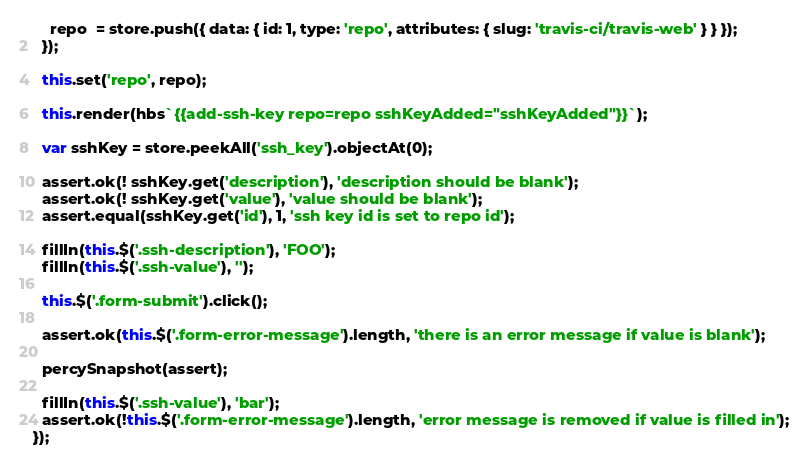Convert code to text. <code><loc_0><loc_0><loc_500><loc_500><_JavaScript_>    repo  = store.push({ data: { id: 1, type: 'repo', attributes: { slug: 'travis-ci/travis-web' } } });
  });

  this.set('repo', repo);

  this.render(hbs`{{add-ssh-key repo=repo sshKeyAdded="sshKeyAdded"}}`);

  var sshKey = store.peekAll('ssh_key').objectAt(0);

  assert.ok(! sshKey.get('description'), 'description should be blank');
  assert.ok(! sshKey.get('value'), 'value should be blank');
  assert.equal(sshKey.get('id'), 1, 'ssh key id is set to repo id');

  fillIn(this.$('.ssh-description'), 'FOO');
  fillIn(this.$('.ssh-value'), '');

  this.$('.form-submit').click();

  assert.ok(this.$('.form-error-message').length, 'there is an error message if value is blank');

  percySnapshot(assert);

  fillIn(this.$('.ssh-value'), 'bar');
  assert.ok(!this.$('.form-error-message').length, 'error message is removed if value is filled in');
});
</code> 